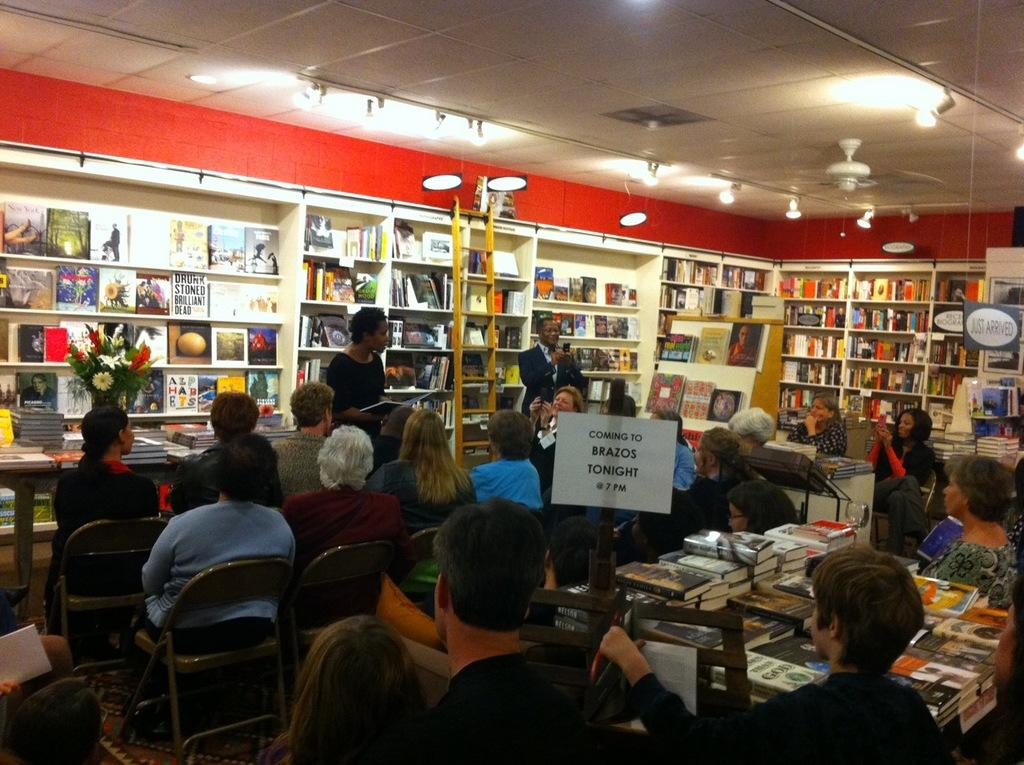What are the persons in the image doing? The persons in the image are sitting on chairs. What objects can be seen on the tables? There are books on tables in the image. How are the racks in the image being utilized? The racks are filled with books and things. What type of lighting is present in the image? There are lights on top in the image. What are the standing persons doing? Two persons are standing in the image. What additional object can be seen in the image? There is a ladder in the image. How does one make a wish come true in the image? There is no mention of wishes or wish-making in the image; it primarily features persons sitting, standing, and interacting with books and furniture. 